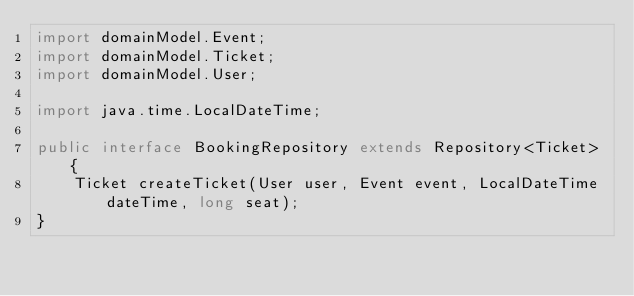<code> <loc_0><loc_0><loc_500><loc_500><_Java_>import domainModel.Event;
import domainModel.Ticket;
import domainModel.User;

import java.time.LocalDateTime;

public interface BookingRepository extends Repository<Ticket> {
    Ticket createTicket(User user, Event event, LocalDateTime dateTime, long seat);
}
</code> 